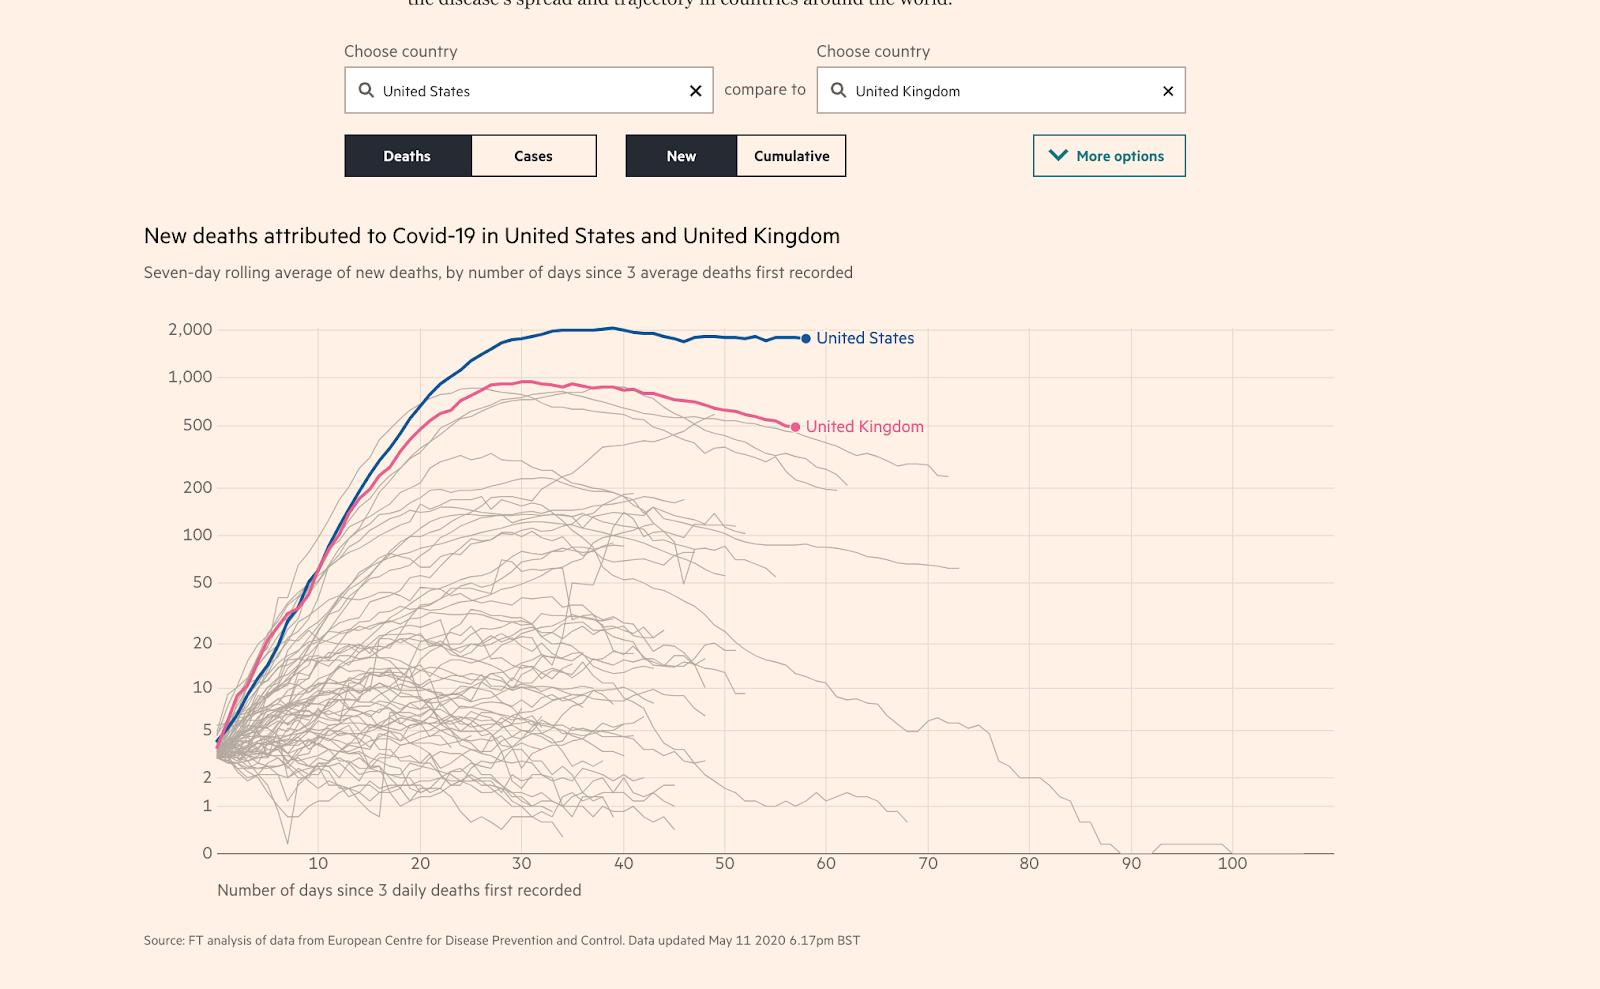Identify some key points in this picture. The map shows the United Kingdom, represented by the red line. The blue line represents the United States. 